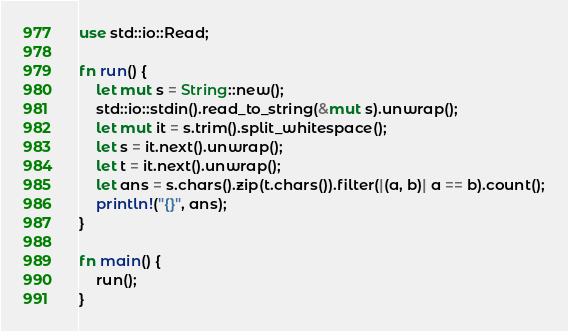<code> <loc_0><loc_0><loc_500><loc_500><_Rust_>use std::io::Read;

fn run() {
    let mut s = String::new();
    std::io::stdin().read_to_string(&mut s).unwrap();
    let mut it = s.trim().split_whitespace();
    let s = it.next().unwrap();
    let t = it.next().unwrap();
    let ans = s.chars().zip(t.chars()).filter(|(a, b)| a == b).count();
    println!("{}", ans);
}

fn main() {
    run();
}</code> 